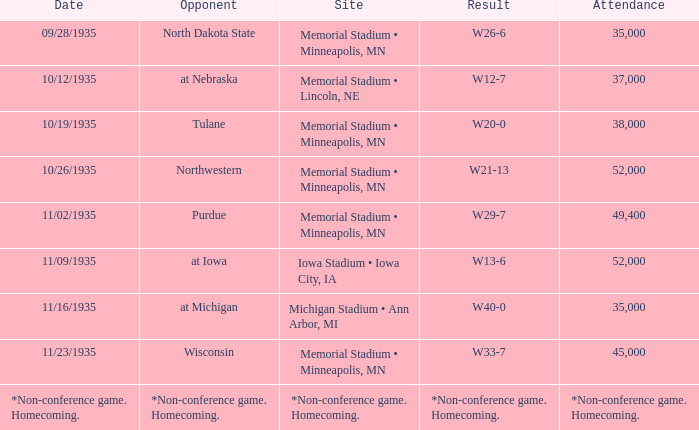On what date was the outcome w20-0? 10/19/1935. 